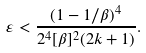Convert formula to latex. <formula><loc_0><loc_0><loc_500><loc_500>\varepsilon < \frac { ( 1 - 1 / \beta ) ^ { 4 } } { 2 ^ { 4 } [ \beta ] ^ { 2 } ( 2 k + 1 ) } .</formula> 